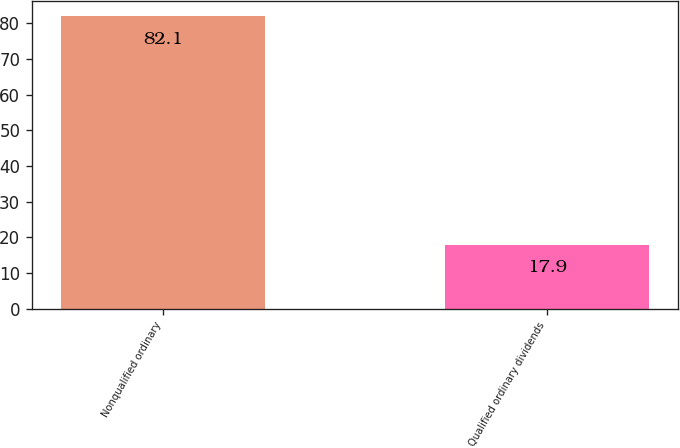<chart> <loc_0><loc_0><loc_500><loc_500><bar_chart><fcel>Nonqualified ordinary<fcel>Qualified ordinary dividends<nl><fcel>82.1<fcel>17.9<nl></chart> 